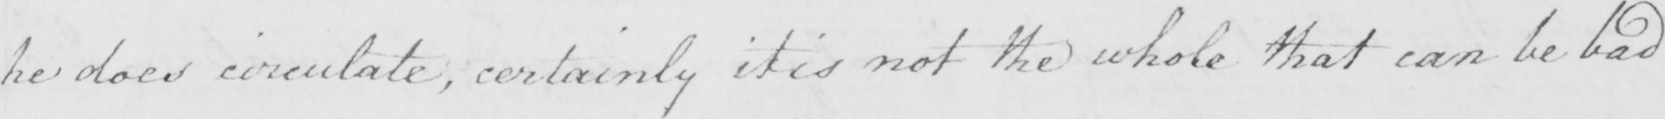Please transcribe the handwritten text in this image. he does circulate , certainly it is not the whole that can be bad 